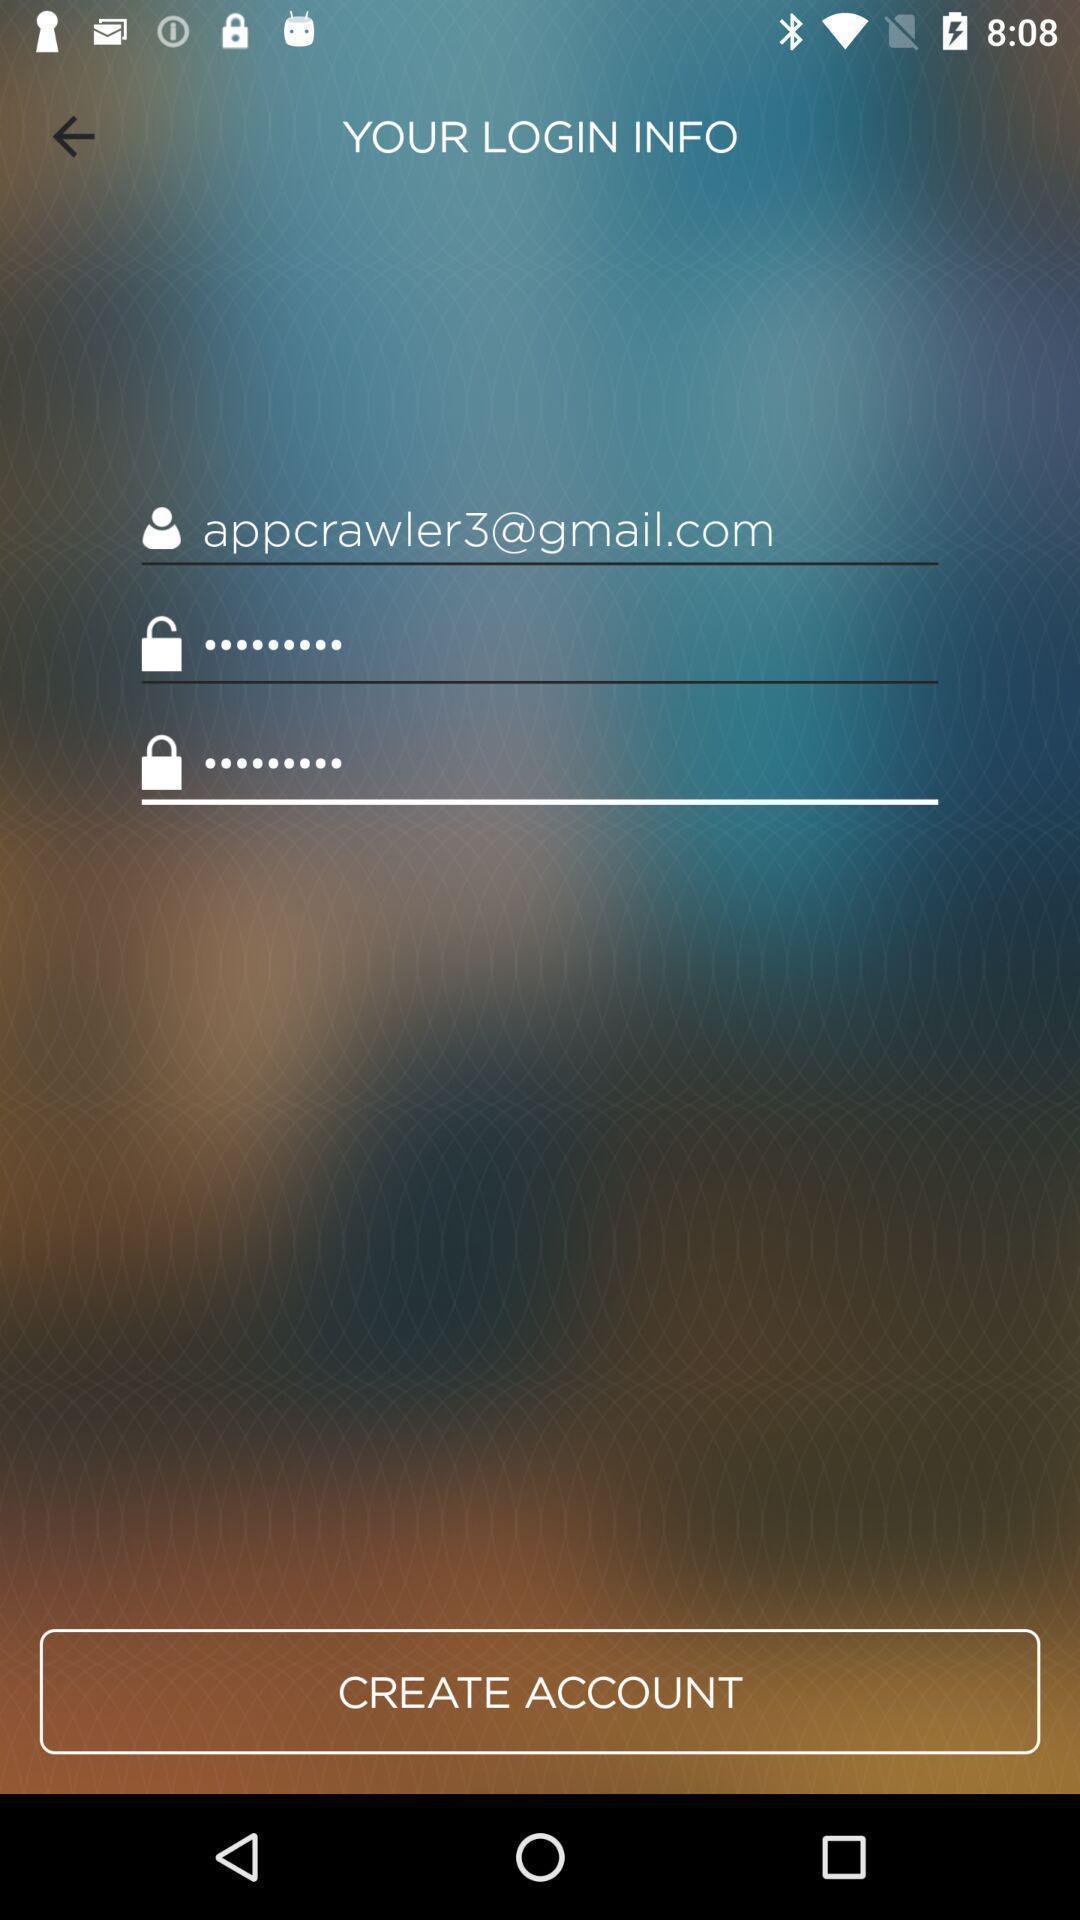Tell me about the visual elements in this screen capture. Welcome page of a social app. 